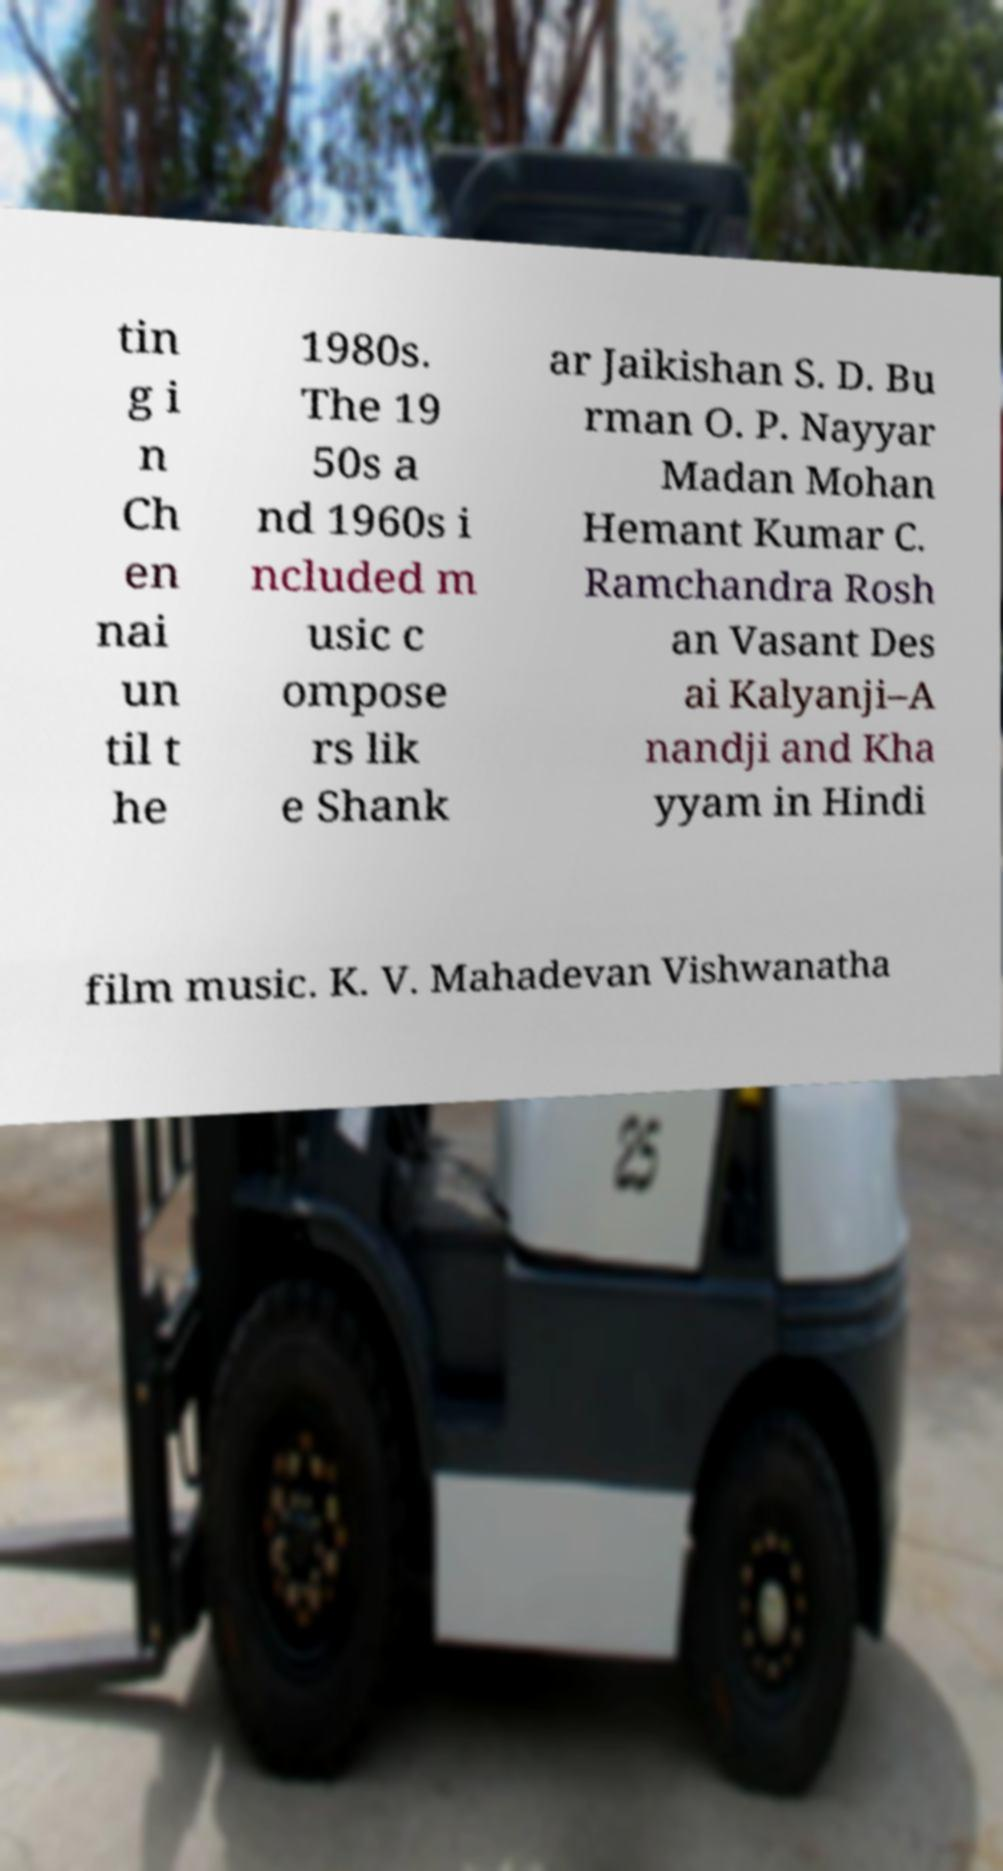There's text embedded in this image that I need extracted. Can you transcribe it verbatim? tin g i n Ch en nai un til t he 1980s. The 19 50s a nd 1960s i ncluded m usic c ompose rs lik e Shank ar Jaikishan S. D. Bu rman O. P. Nayyar Madan Mohan Hemant Kumar C. Ramchandra Rosh an Vasant Des ai Kalyanji–A nandji and Kha yyam in Hindi film music. K. V. Mahadevan Vishwanatha 